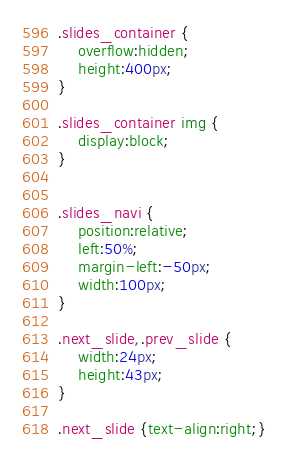Convert code to text. <code><loc_0><loc_0><loc_500><loc_500><_CSS_>.slides_container {
	overflow:hidden;
	height:400px;
}

.slides_container img {
	display:block;
}


.slides_navi {
    position:relative;
    left:50%;
    margin-left:-50px;
    width:100px;
}

.next_slide,.prev_slide {
	width:24px;
	height:43px;
}

.next_slide {text-align:right;}
</code> 